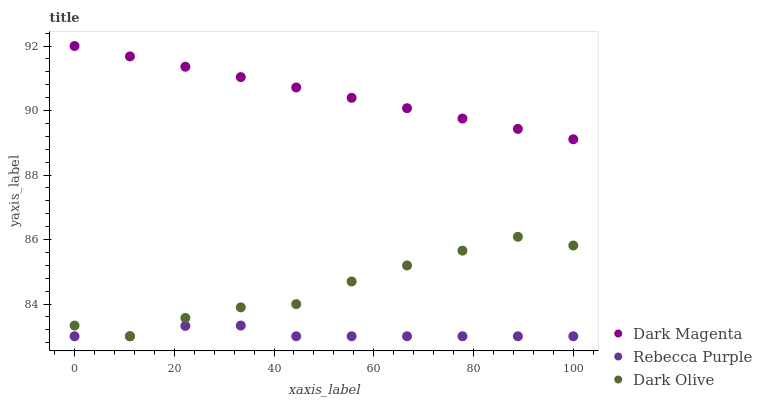Does Rebecca Purple have the minimum area under the curve?
Answer yes or no. Yes. Does Dark Magenta have the maximum area under the curve?
Answer yes or no. Yes. Does Dark Magenta have the minimum area under the curve?
Answer yes or no. No. Does Rebecca Purple have the maximum area under the curve?
Answer yes or no. No. Is Dark Magenta the smoothest?
Answer yes or no. Yes. Is Dark Olive the roughest?
Answer yes or no. Yes. Is Rebecca Purple the smoothest?
Answer yes or no. No. Is Rebecca Purple the roughest?
Answer yes or no. No. Does Dark Olive have the lowest value?
Answer yes or no. Yes. Does Dark Magenta have the lowest value?
Answer yes or no. No. Does Dark Magenta have the highest value?
Answer yes or no. Yes. Does Rebecca Purple have the highest value?
Answer yes or no. No. Is Dark Olive less than Dark Magenta?
Answer yes or no. Yes. Is Dark Magenta greater than Rebecca Purple?
Answer yes or no. Yes. Does Dark Olive intersect Rebecca Purple?
Answer yes or no. Yes. Is Dark Olive less than Rebecca Purple?
Answer yes or no. No. Is Dark Olive greater than Rebecca Purple?
Answer yes or no. No. Does Dark Olive intersect Dark Magenta?
Answer yes or no. No. 